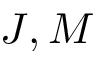<formula> <loc_0><loc_0><loc_500><loc_500>J , M</formula> 